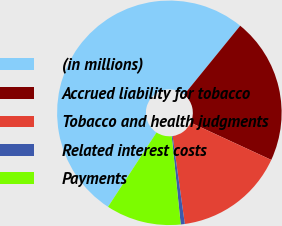Convert chart. <chart><loc_0><loc_0><loc_500><loc_500><pie_chart><fcel>(in millions)<fcel>Accrued liability for tobacco<fcel>Tobacco and health judgments<fcel>Related interest costs<fcel>Payments<nl><fcel>51.67%<fcel>21.02%<fcel>15.91%<fcel>0.59%<fcel>10.81%<nl></chart> 